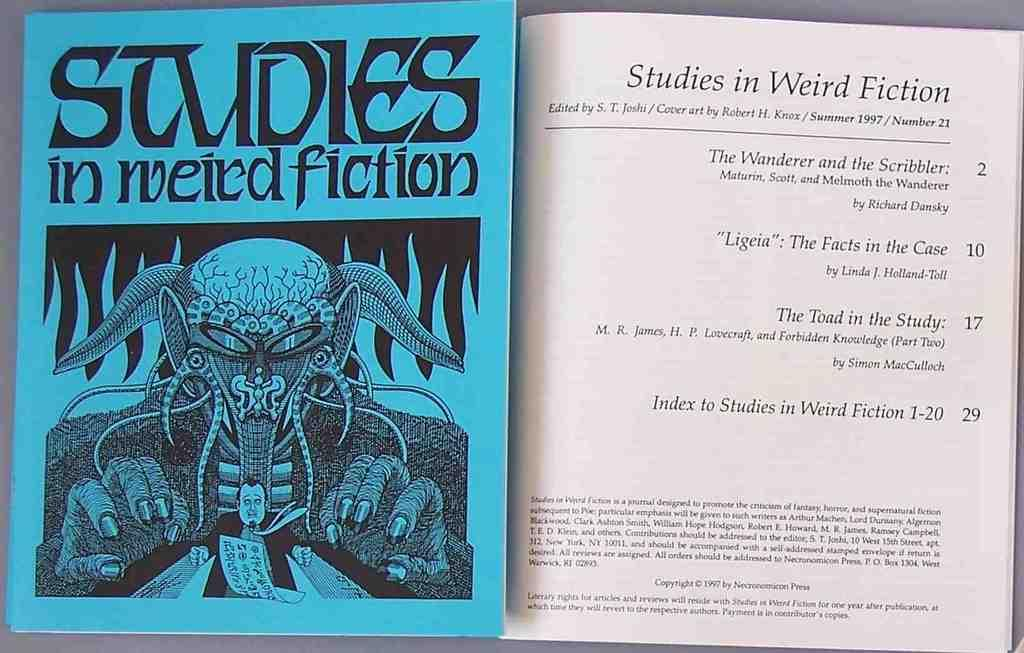<image>
Write a terse but informative summary of the picture. a book that is titled 'studies in weird fiction' 